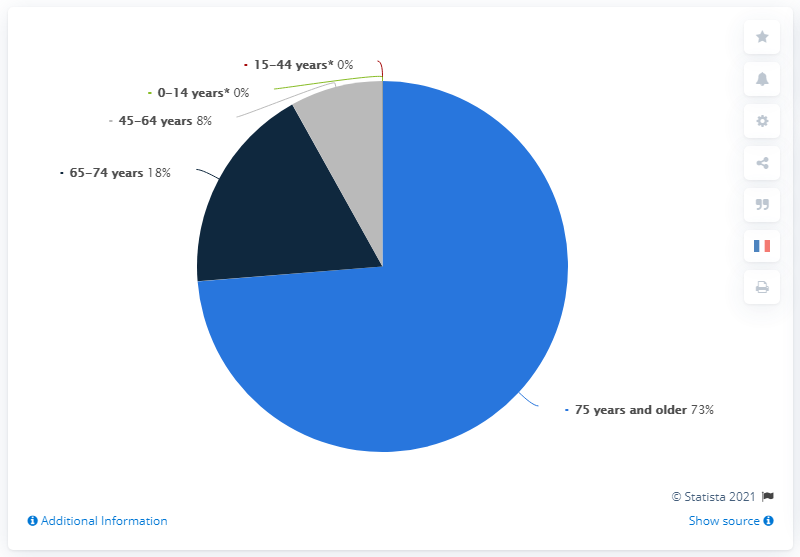Indicate a few pertinent items in this graphic. It is not clear what you are asking. Could you please provide more context or clarify your question? The color that takes up more space in the pie chart is light blue. As of June 22, 2021, it is estimated that 73% of individuals aged 75 and older have been affected by the novel coronavirus. 